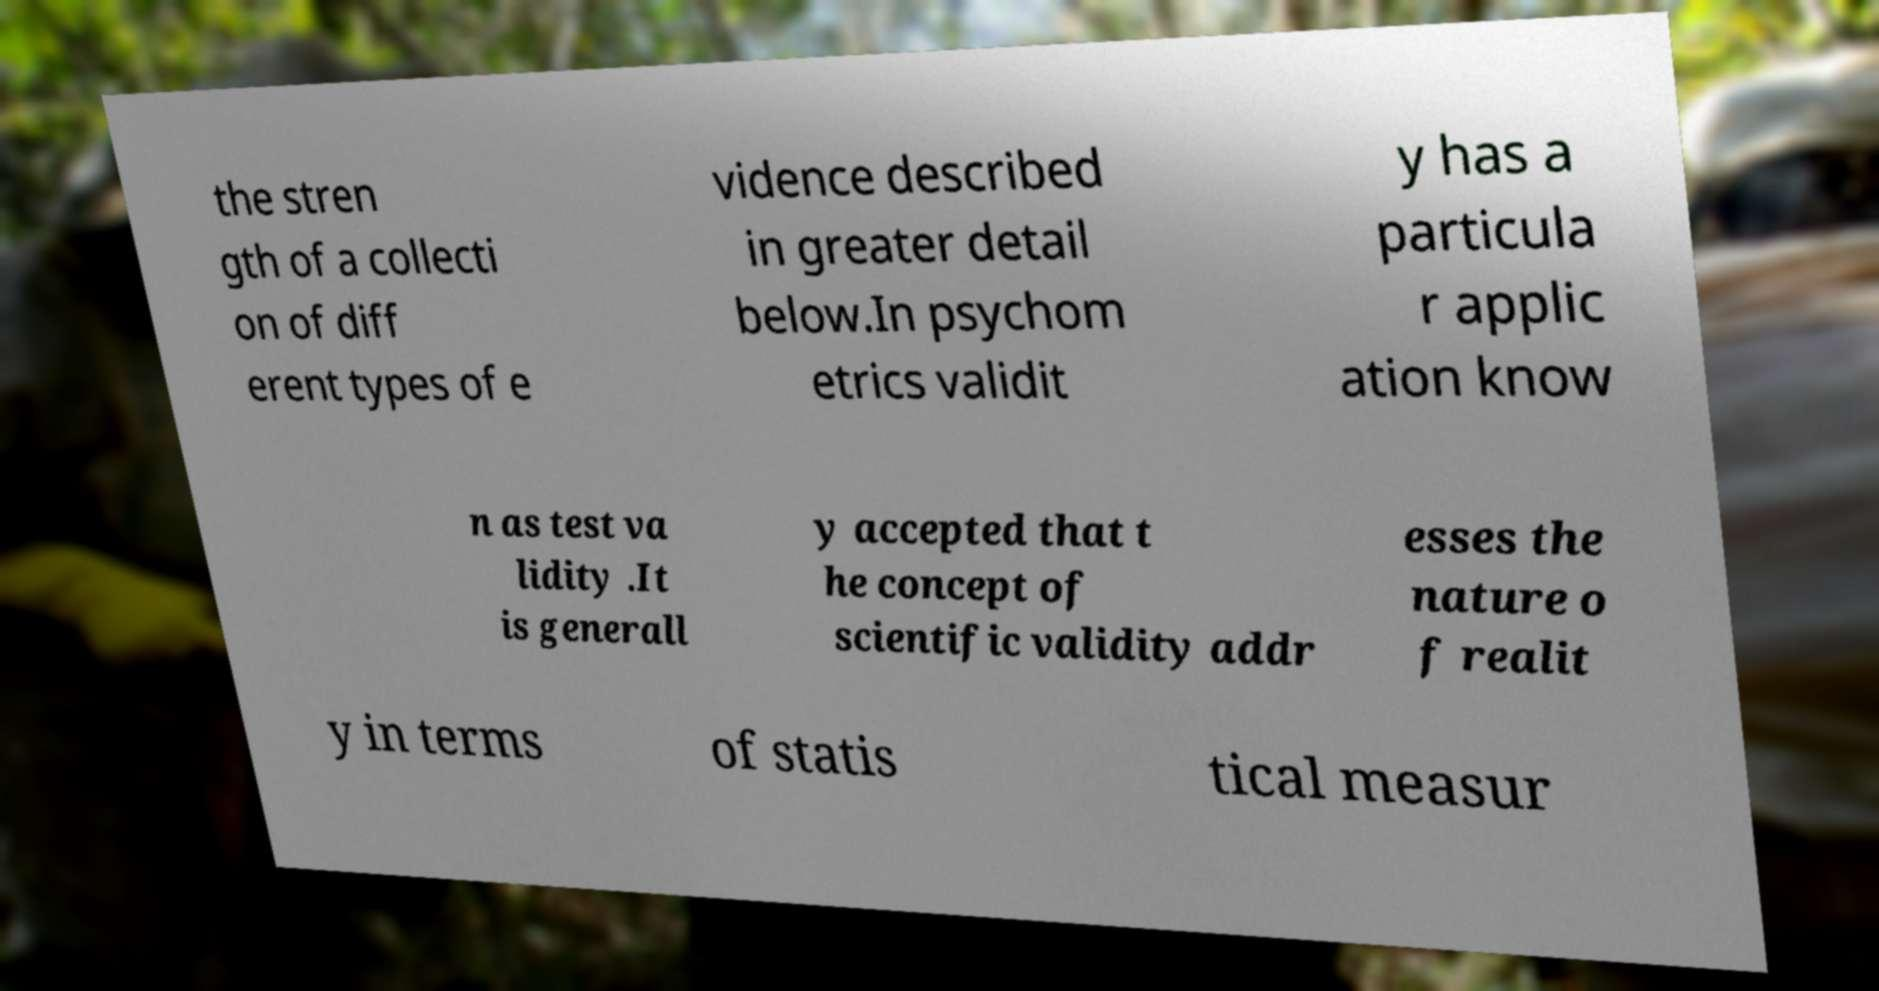Can you read and provide the text displayed in the image?This photo seems to have some interesting text. Can you extract and type it out for me? the stren gth of a collecti on of diff erent types of e vidence described in greater detail below.In psychom etrics validit y has a particula r applic ation know n as test va lidity .It is generall y accepted that t he concept of scientific validity addr esses the nature o f realit y in terms of statis tical measur 